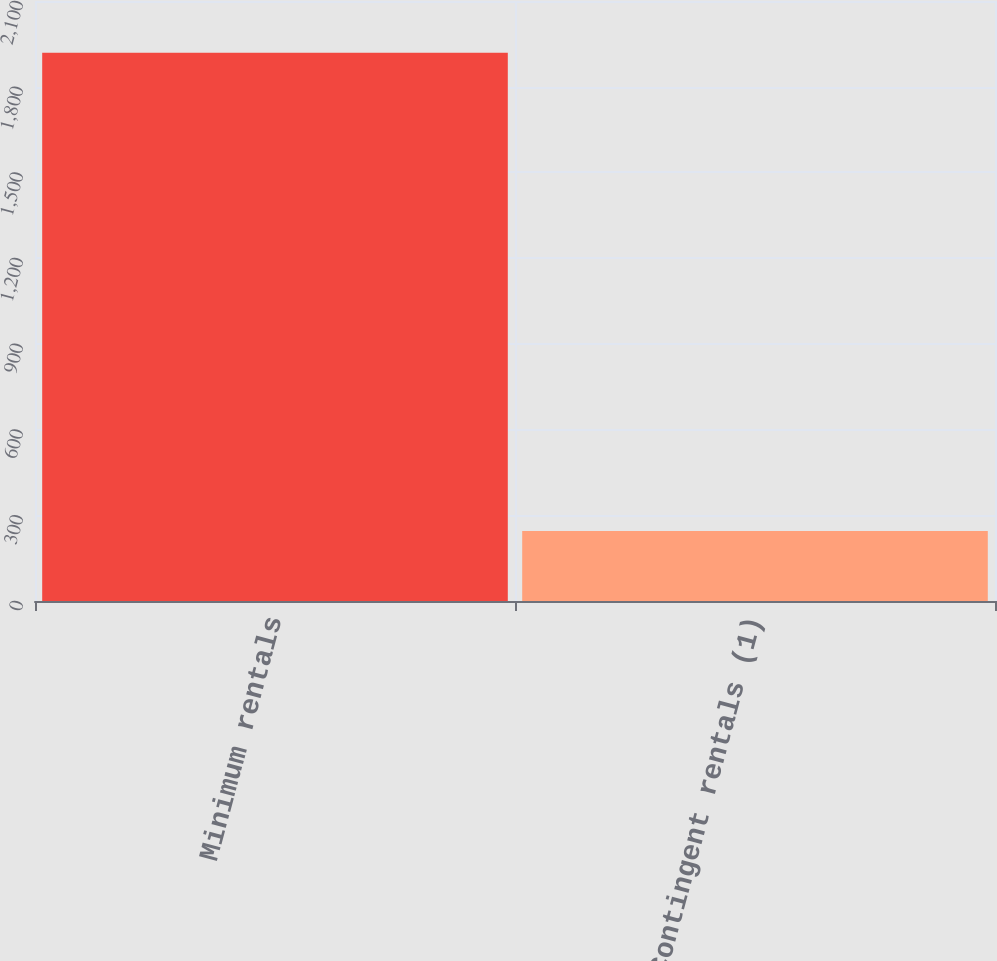Convert chart. <chart><loc_0><loc_0><loc_500><loc_500><bar_chart><fcel>Minimum rentals<fcel>Contingent rentals (1)<nl><fcel>1919<fcel>245<nl></chart> 